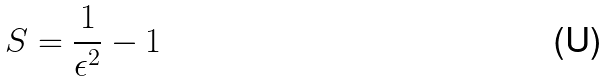Convert formula to latex. <formula><loc_0><loc_0><loc_500><loc_500>S = \frac { 1 } { \epsilon ^ { 2 } } - 1</formula> 